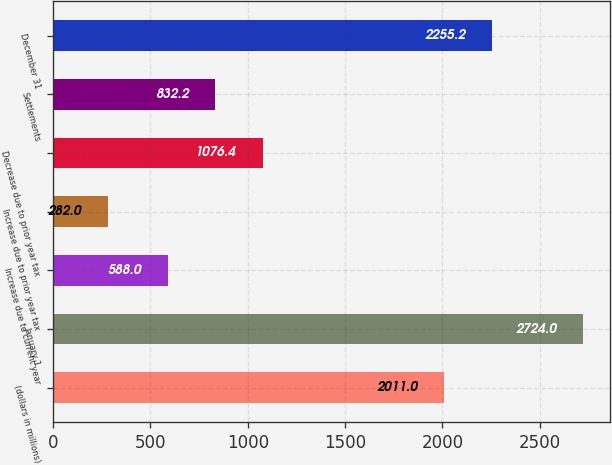Convert chart to OTSL. <chart><loc_0><loc_0><loc_500><loc_500><bar_chart><fcel>(dollars in millions)<fcel>January 1<fcel>Increase due to current year<fcel>Increase due to prior year tax<fcel>Decrease due to prior year tax<fcel>Settlements<fcel>December 31<nl><fcel>2011<fcel>2724<fcel>588<fcel>282<fcel>1076.4<fcel>832.2<fcel>2255.2<nl></chart> 